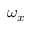Convert formula to latex. <formula><loc_0><loc_0><loc_500><loc_500>\omega _ { x }</formula> 